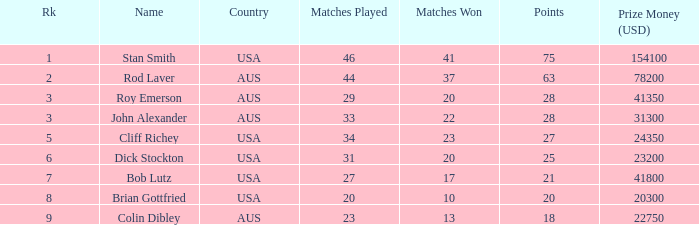What number of matches did colin dibley triumph in? 13.0. Can you parse all the data within this table? {'header': ['Rk', 'Name', 'Country', 'Matches Played', 'Matches Won', 'Points', 'Prize Money (USD)'], 'rows': [['1', 'Stan Smith', 'USA', '46', '41', '75', '154100'], ['2', 'Rod Laver', 'AUS', '44', '37', '63', '78200'], ['3', 'Roy Emerson', 'AUS', '29', '20', '28', '41350'], ['3', 'John Alexander', 'AUS', '33', '22', '28', '31300'], ['5', 'Cliff Richey', 'USA', '34', '23', '27', '24350'], ['6', 'Dick Stockton', 'USA', '31', '20', '25', '23200'], ['7', 'Bob Lutz', 'USA', '27', '17', '21', '41800'], ['8', 'Brian Gottfried', 'USA', '20', '10', '20', '20300'], ['9', 'Colin Dibley', 'AUS', '23', '13', '18', '22750']]} 